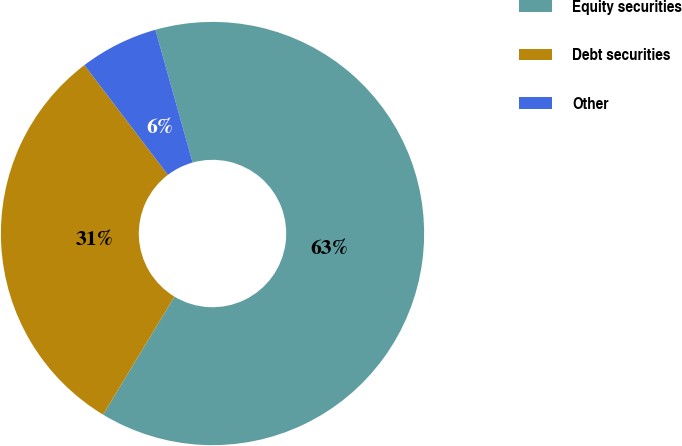Convert chart to OTSL. <chart><loc_0><loc_0><loc_500><loc_500><pie_chart><fcel>Equity securities<fcel>Debt securities<fcel>Other<nl><fcel>63.0%<fcel>31.0%<fcel>6.0%<nl></chart> 